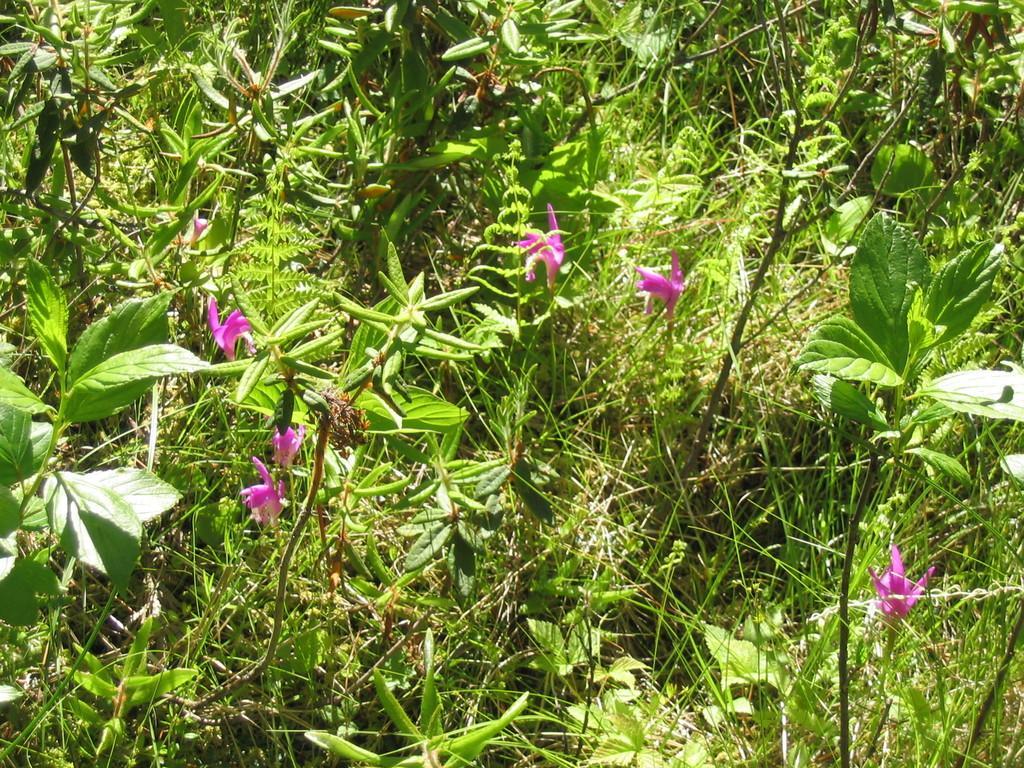Could you give a brief overview of what you see in this image? In this picture we can see plants with the flowers and behind the flowers there is grass. 